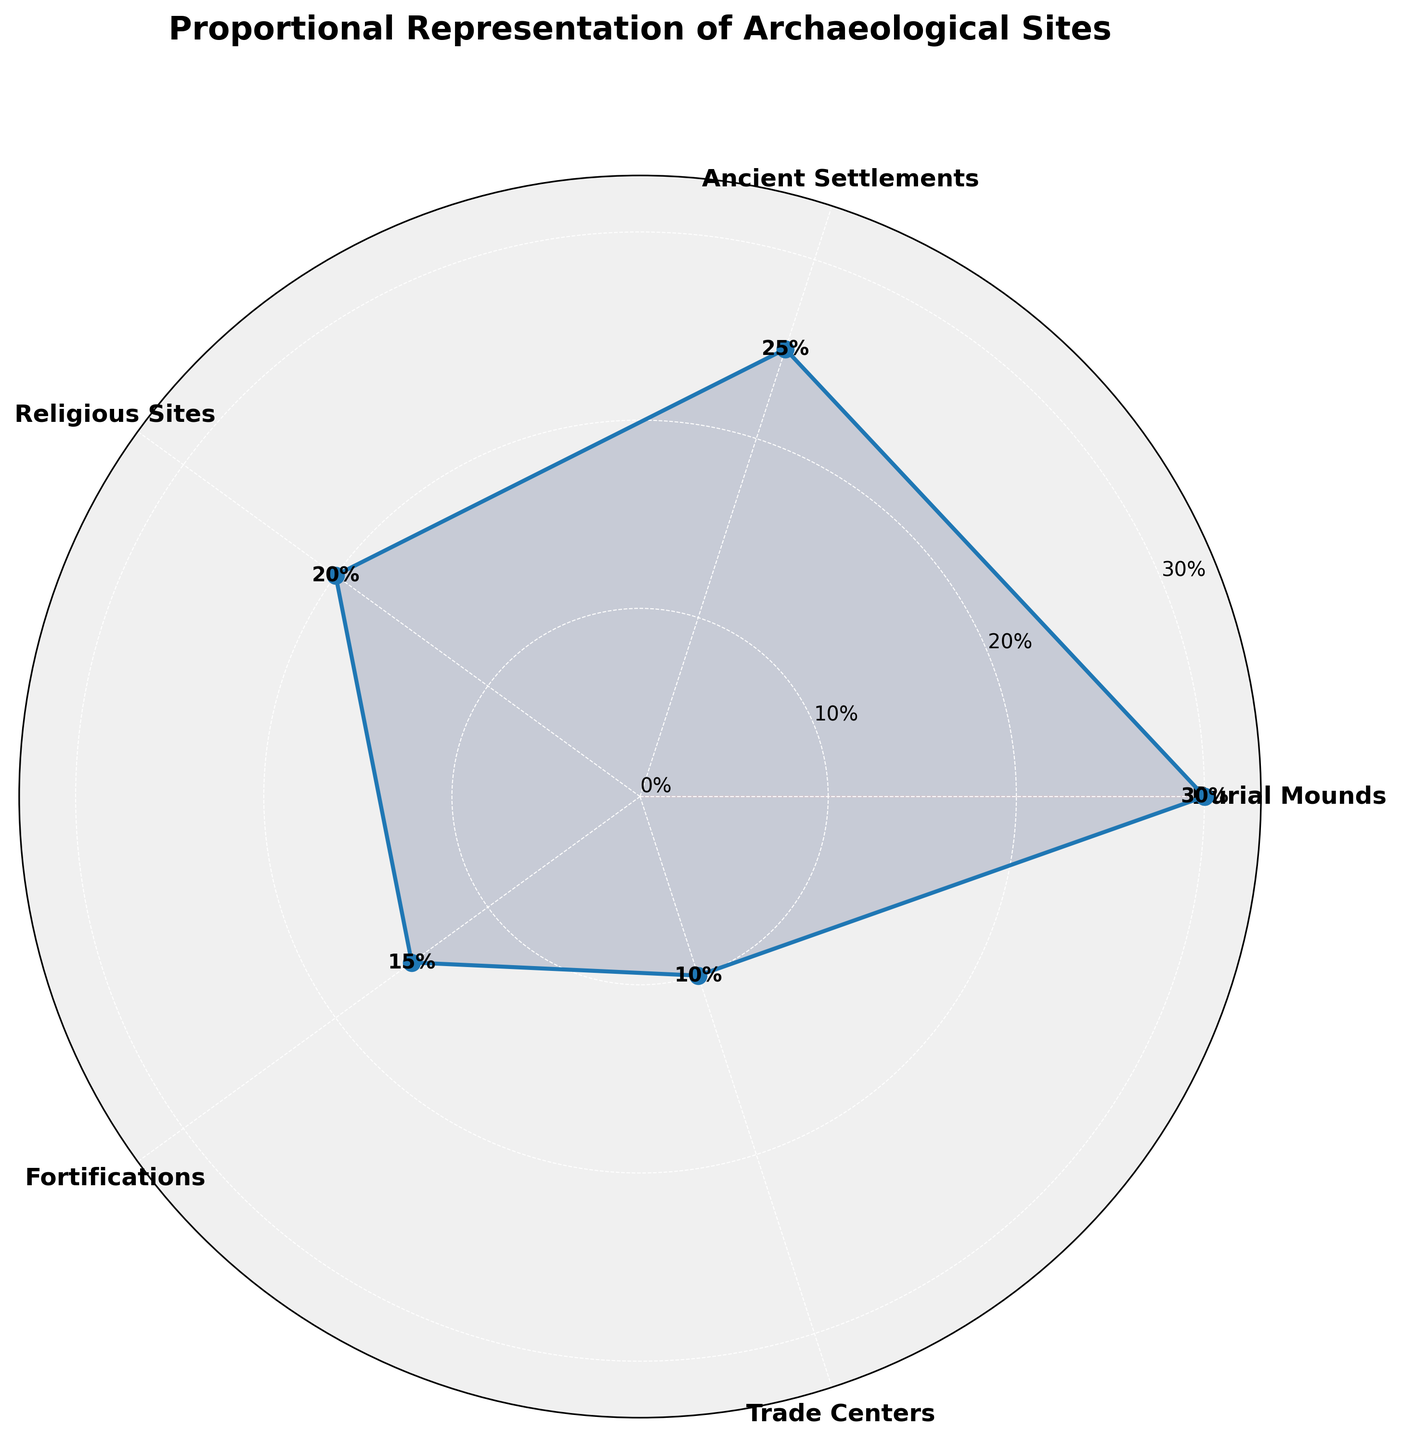What is the title of the figure? The title is the text displayed at the top of the figure. It usually provides an overview or summary of what the figure represents. In this case, the title is "Proportional Representation of Archaeological Sites."
Answer: Proportional Representation of Archaeological Sites What proportion of the archaeological sites are Ancient Settlements? The polar area chart displays each category and its corresponding proportion. The proportion for Ancient Settlements is labeled on the chart.
Answer: 25% Which type of archaeological site has the largest representation? By looking at the segments in the polar area chart, the largest segment corresponds to the type with the highest proportion. Here, Burial Mounds has the largest segment.
Answer: Burial Mounds What is the combined proportion of Religious Sites and Trade Centers? To find the combined proportion, add the individual proportions of Religious Sites and Trade Centers. Religious Sites are 20% and Trade Centers are 10%, so 20% + 10% = 30%.
Answer: 30% How many types of archaeological sites are represented in the chart? Each segment of the polar area chart corresponds to a different type of archaeological site. By counting the segments, we can find the number of types represented.
Answer: 5 Which type of site has the smallest representation, and what is its proportion? The segment corresponding to the smallest proportion indicates the type of site with the smallest representation. Here, it is Trade Centers with 10%.
Answer: Trade Centers, 10% By how much does the proportion of Burial Mounds exceed that of Fortifications? To find the difference, subtract the proportion of Fortifications from the proportion of Burial Mounds. Burial Mounds are 30% and Fortifications are 15%, so 30% - 15% = 15%.
Answer: 15% Which two types of archaeological sites have a combined proportion equal to the proportion of Burial Mounds? By examining the proportions, determine which two types sum up to the proportion of Burial Mounds (30%). Ancient Settlements (25%) and Trade Centers (10%) combined would be more (35%). The correct pair is Religious Sites (20%) and Fortifications (15%), but their sum is 35%. The right pair does not seem to be directly present, so this must be an internal error. Another correction may be needed for the paired options in initial data or plotting.
Answer: No correct pair within current data Is the proportion of Fortifications greater than that of Trade Centers? Compare the segments or the textual proportions for Fortifications (15%) and Trade Centers (10%). Since 15% is greater than 10%, the proportion of Fortifications is indeed greater than that of Trade Centers.
Answer: Yes What are the colors used in the chart, and are they visibly different? The chart uses different pastel colors to differentiate between the categories. Each category is filled with subtly unique pastel colors to aid visual differentiation.
Answer: Yes, pastel colors, visibly different 